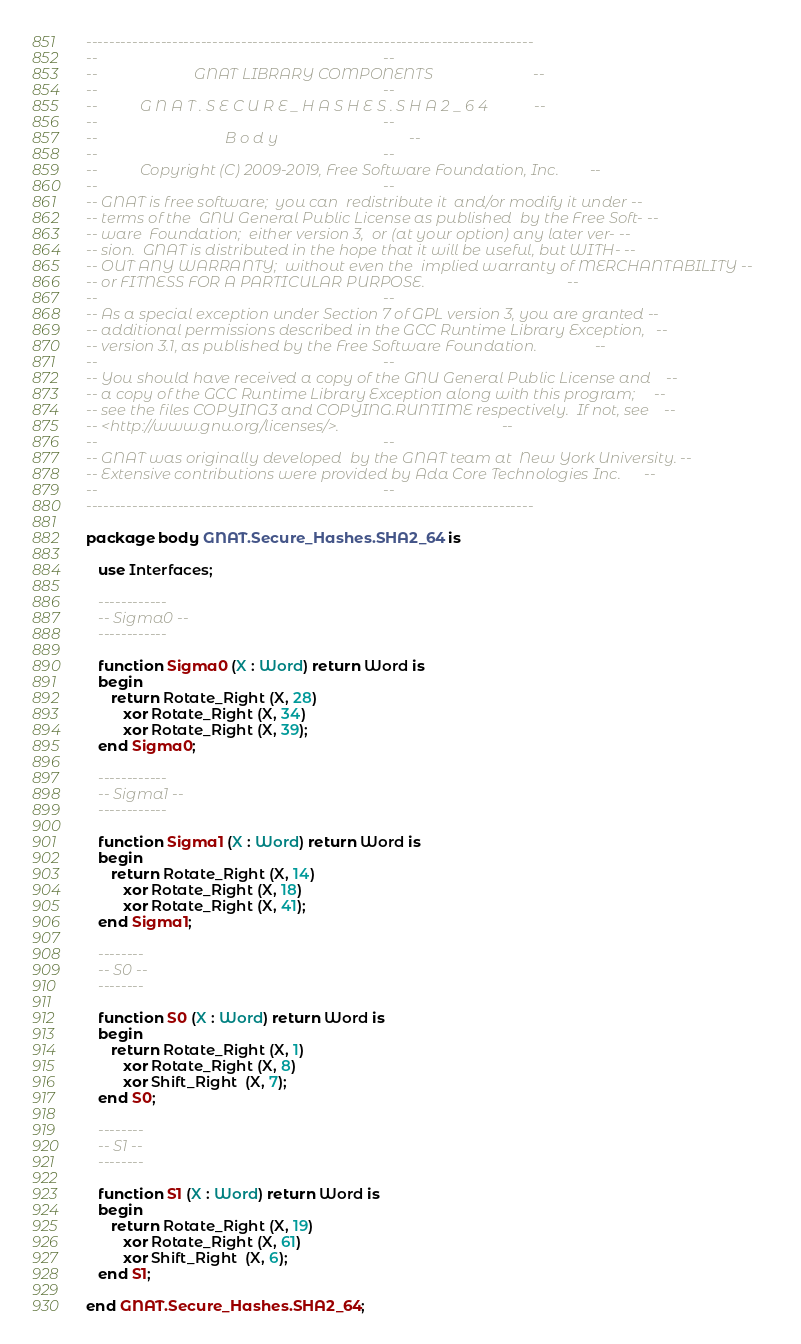<code> <loc_0><loc_0><loc_500><loc_500><_Ada_>------------------------------------------------------------------------------
--                                                                          --
--                         GNAT LIBRARY COMPONENTS                          --
--                                                                          --
--           G N A T . S E C U R E _ H A S H E S . S H A 2 _ 6 4            --
--                                                                          --
--                                 B o d y                                  --
--                                                                          --
--           Copyright (C) 2009-2019, Free Software Foundation, Inc.        --
--                                                                          --
-- GNAT is free software;  you can  redistribute it  and/or modify it under --
-- terms of the  GNU General Public License as published  by the Free Soft- --
-- ware  Foundation;  either version 3,  or (at your option) any later ver- --
-- sion.  GNAT is distributed in the hope that it will be useful, but WITH- --
-- OUT ANY WARRANTY;  without even the  implied warranty of MERCHANTABILITY --
-- or FITNESS FOR A PARTICULAR PURPOSE.                                     --
--                                                                          --
-- As a special exception under Section 7 of GPL version 3, you are granted --
-- additional permissions described in the GCC Runtime Library Exception,   --
-- version 3.1, as published by the Free Software Foundation.               --
--                                                                          --
-- You should have received a copy of the GNU General Public License and    --
-- a copy of the GCC Runtime Library Exception along with this program;     --
-- see the files COPYING3 and COPYING.RUNTIME respectively.  If not, see    --
-- <http://www.gnu.org/licenses/>.                                          --
--                                                                          --
-- GNAT was originally developed  by the GNAT team at  New York University. --
-- Extensive contributions were provided by Ada Core Technologies Inc.      --
--                                                                          --
------------------------------------------------------------------------------

package body GNAT.Secure_Hashes.SHA2_64 is

   use Interfaces;

   ------------
   -- Sigma0 --
   ------------

   function Sigma0 (X : Word) return Word is
   begin
      return Rotate_Right (X, 28)
         xor Rotate_Right (X, 34)
         xor Rotate_Right (X, 39);
   end Sigma0;

   ------------
   -- Sigma1 --
   ------------

   function Sigma1 (X : Word) return Word is
   begin
      return Rotate_Right (X, 14)
         xor Rotate_Right (X, 18)
         xor Rotate_Right (X, 41);
   end Sigma1;

   --------
   -- S0 --
   --------

   function S0 (X : Word) return Word is
   begin
      return Rotate_Right (X, 1)
         xor Rotate_Right (X, 8)
         xor Shift_Right  (X, 7);
   end S0;

   --------
   -- S1 --
   --------

   function S1 (X : Word) return Word is
   begin
      return Rotate_Right (X, 19)
         xor Rotate_Right (X, 61)
         xor Shift_Right  (X, 6);
   end S1;

end GNAT.Secure_Hashes.SHA2_64;
</code> 